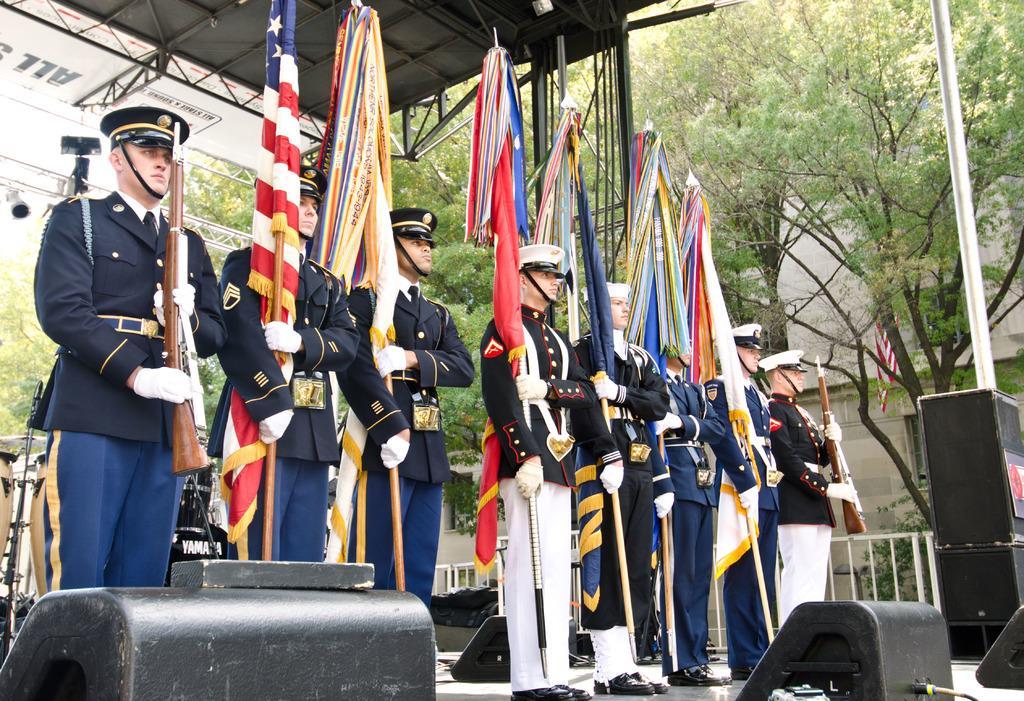Can you describe this image briefly? In this image there are people holding the flags and guns. In front of them there are some objects. Behind them there are musical instruments. In the background of the image there is a metal fence. There are buildings, trees. At the top of the image there are metal rods. 